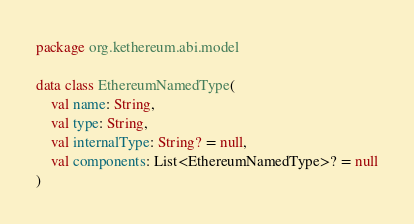Convert code to text. <code><loc_0><loc_0><loc_500><loc_500><_Kotlin_>package org.kethereum.abi.model

data class EthereumNamedType(
    val name: String,
    val type: String,
    val internalType: String? = null,
    val components: List<EthereumNamedType>? = null
)</code> 